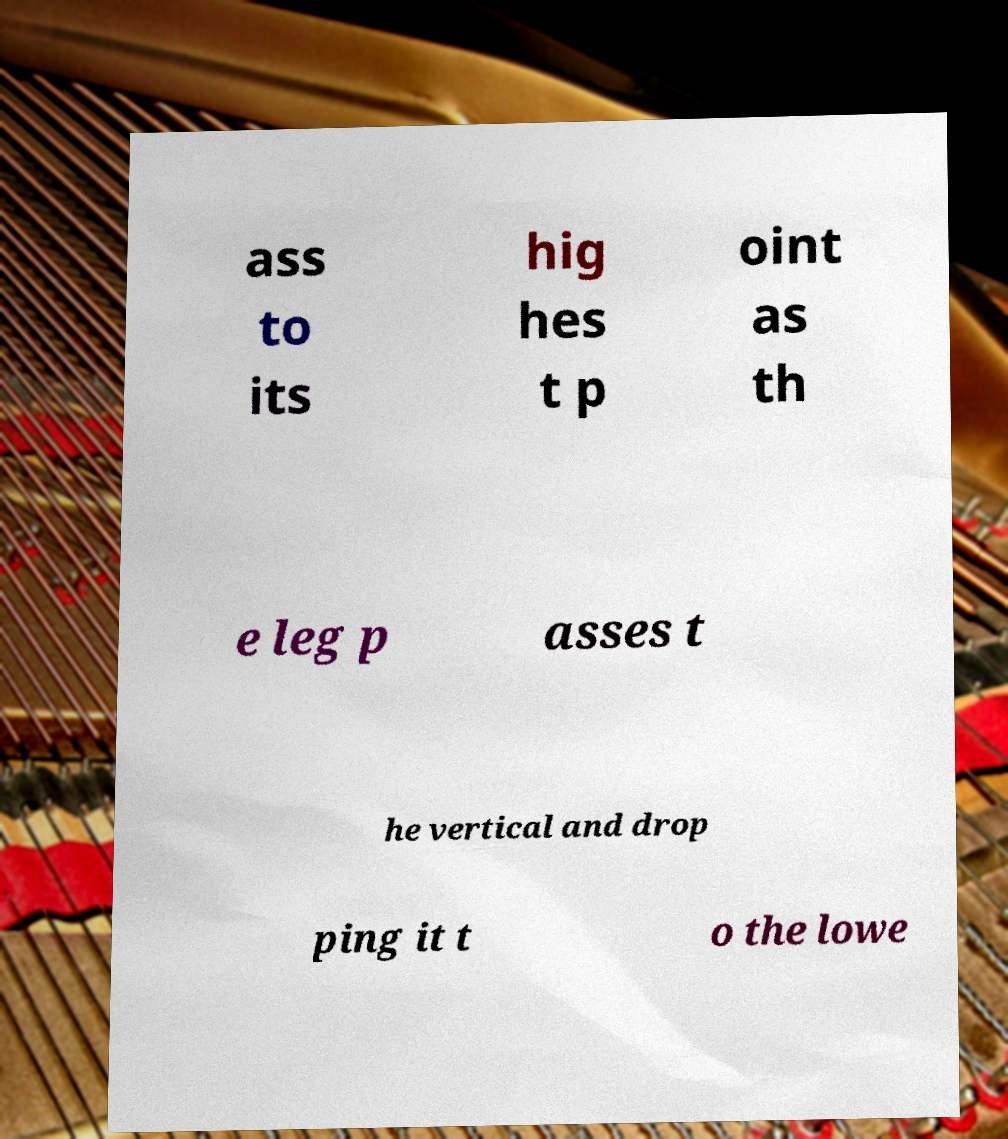Please identify and transcribe the text found in this image. ass to its hig hes t p oint as th e leg p asses t he vertical and drop ping it t o the lowe 